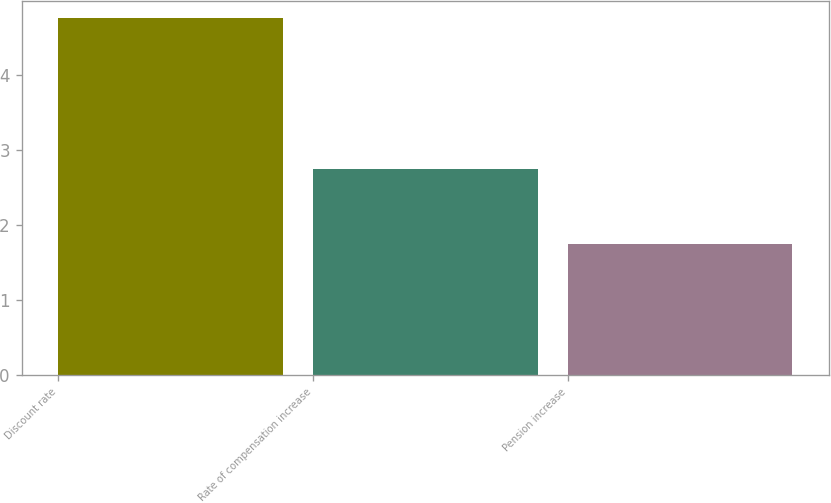Convert chart. <chart><loc_0><loc_0><loc_500><loc_500><bar_chart><fcel>Discount rate<fcel>Rate of compensation increase<fcel>Pension increase<nl><fcel>4.76<fcel>2.75<fcel>1.75<nl></chart> 